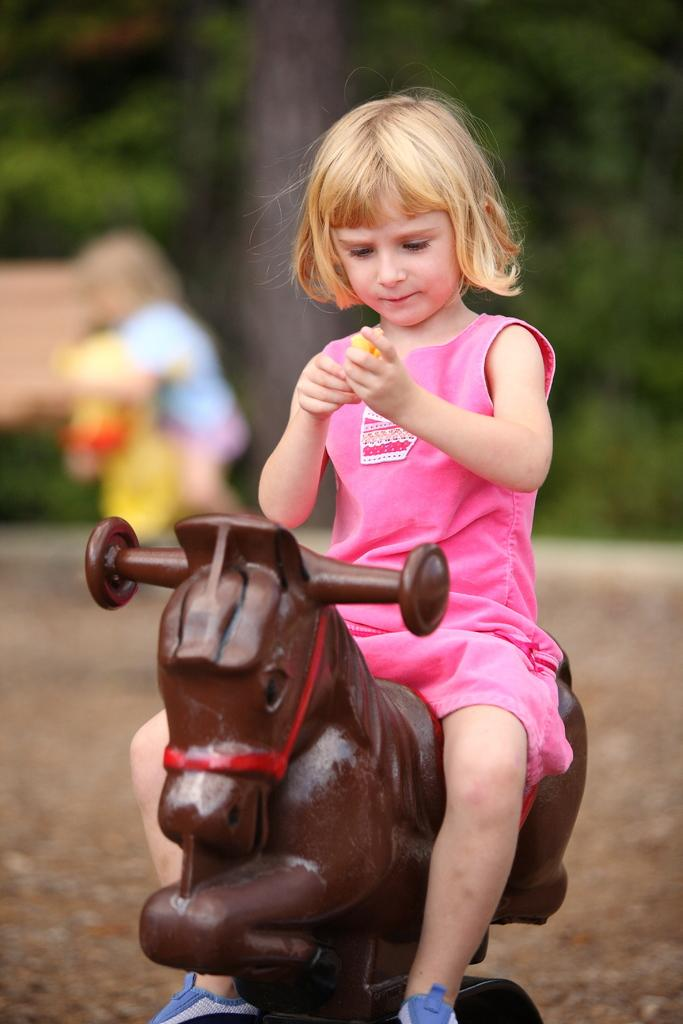Who is the main subject in the image? There is a girl in the image. What is the girl doing in the image? The girl is riding a horse. Can you describe the background of the image? The background of the image is blurred. What type of quince can be seen in the girl's hand in the image? There is no quince present in the image; the girl is riding a horse. What color is the orange in the background of the image? There is no orange present in the image; the background is blurred. 